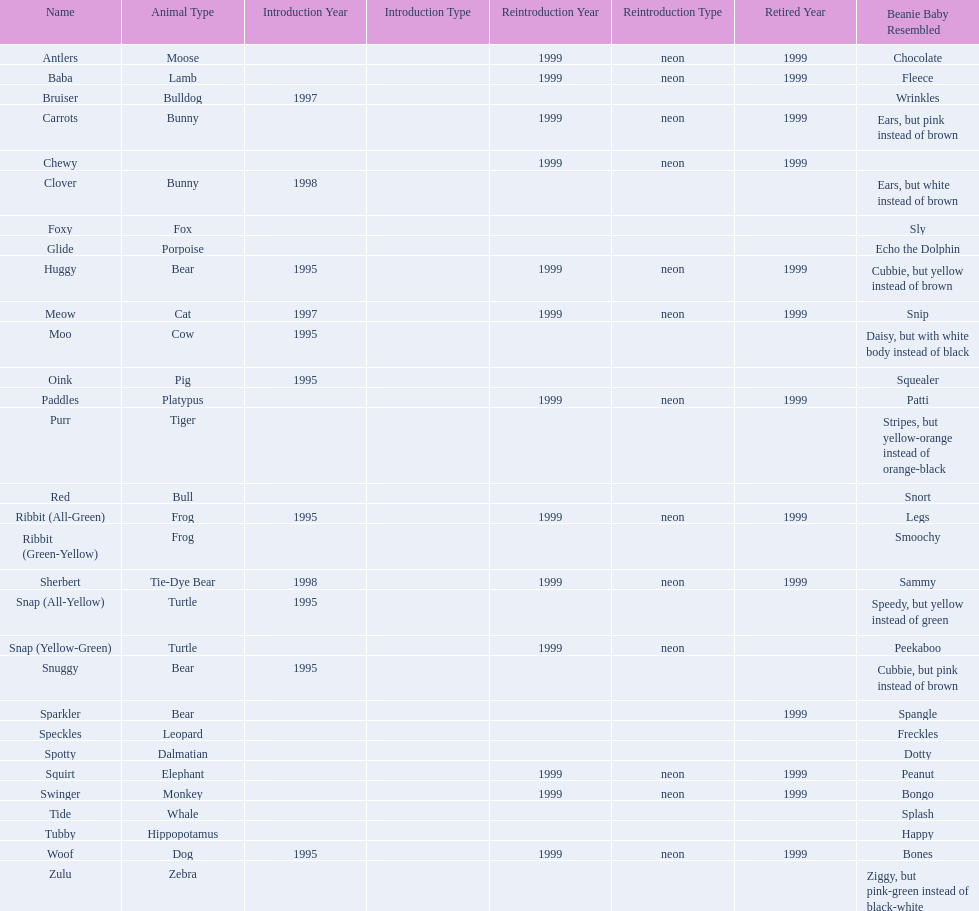What animals are pillow pals? Moose, Lamb, Bulldog, Bunny, Bunny, Fox, Porpoise, Bear, Cat, Cow, Pig, Platypus, Tiger, Bull, Frog, Frog, Tie-Dye Bear, Turtle, Turtle, Bear, Bear, Leopard, Dalmatian, Elephant, Monkey, Whale, Hippopotamus, Dog, Zebra. What is the name of the dalmatian? Spotty. 